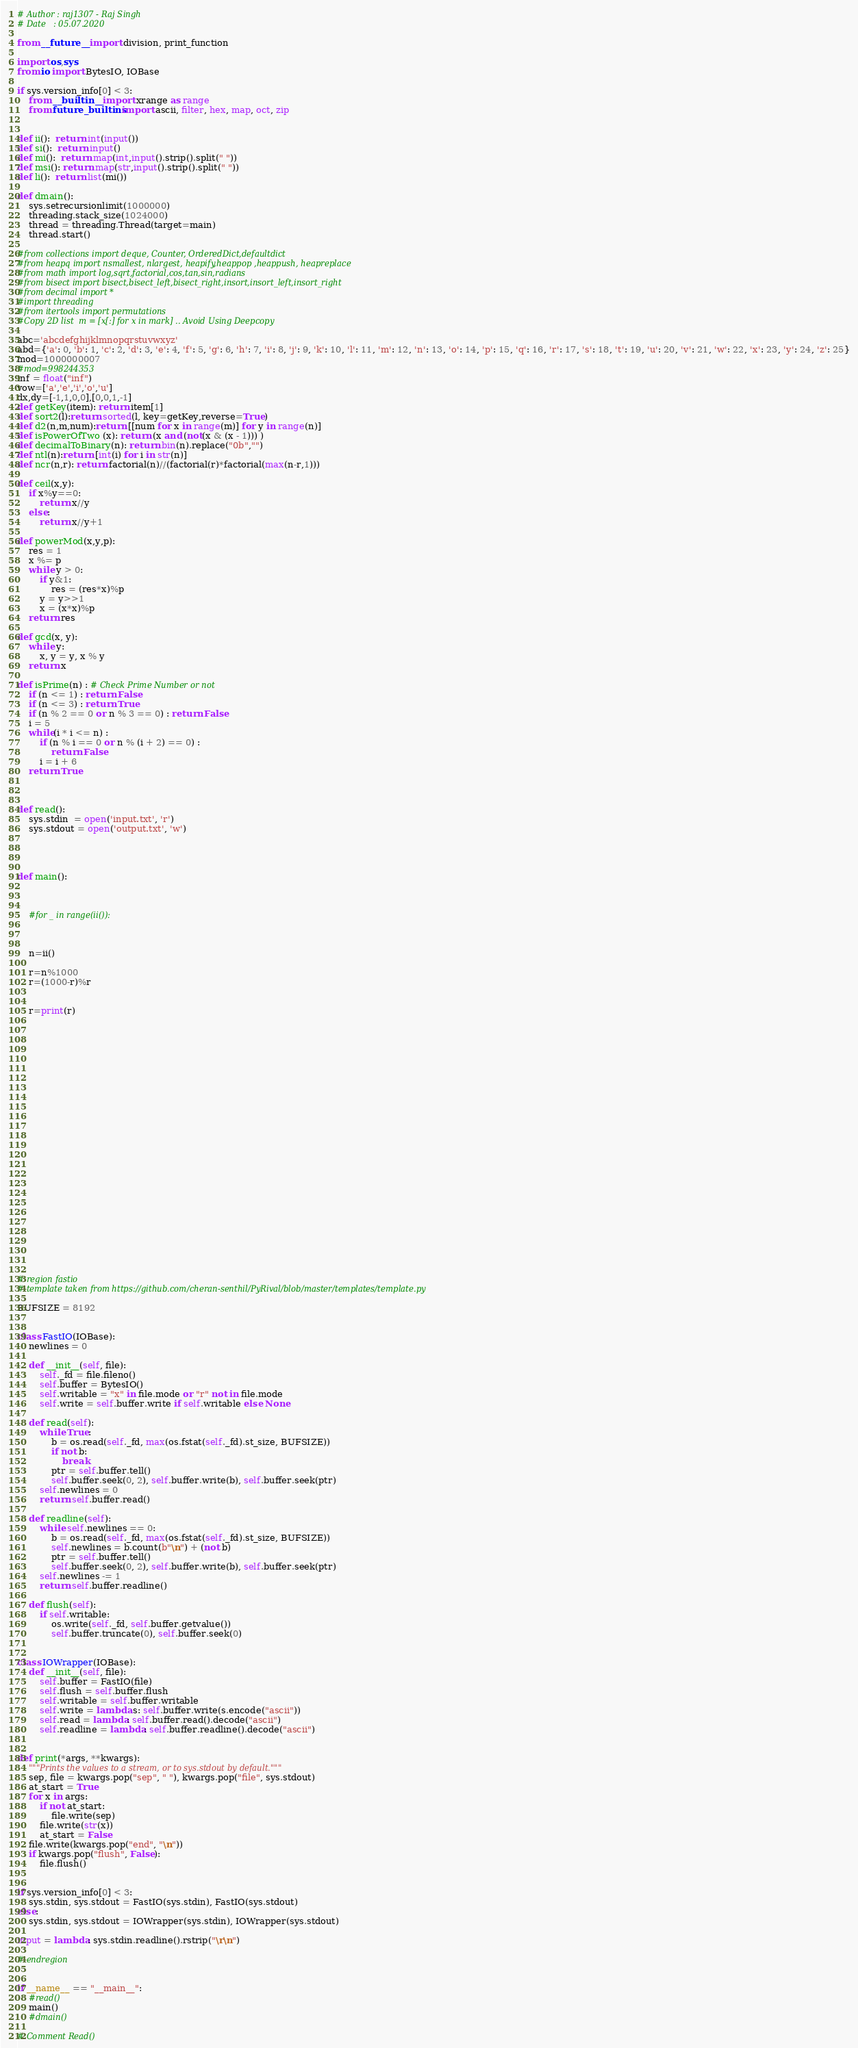<code> <loc_0><loc_0><loc_500><loc_500><_Python_>
# Author : raj1307 - Raj Singh
# Date   : 05.07.2020

from __future__ import division, print_function

import os,sys
from io import BytesIO, IOBase

if sys.version_info[0] < 3:
    from __builtin__ import xrange as range
    from future_builtins import ascii, filter, hex, map, oct, zip


def ii():  return int(input())
def si():  return input()
def mi():  return map(int,input().strip().split(" "))
def msi(): return map(str,input().strip().split(" "))
def li():  return list(mi())

def dmain():
    sys.setrecursionlimit(1000000)
    threading.stack_size(1024000)
    thread = threading.Thread(target=main)
    thread.start()
    
#from collections import deque, Counter, OrderedDict,defaultdict
#from heapq import nsmallest, nlargest, heapify,heappop ,heappush, heapreplace
#from math import log,sqrt,factorial,cos,tan,sin,radians
#from bisect import bisect,bisect_left,bisect_right,insort,insort_left,insort_right
#from decimal import *
#import threading
#from itertools import permutations
#Copy 2D list  m = [x[:] for x in mark] .. Avoid Using Deepcopy

abc='abcdefghijklmnopqrstuvwxyz'
abd={'a': 0, 'b': 1, 'c': 2, 'd': 3, 'e': 4, 'f': 5, 'g': 6, 'h': 7, 'i': 8, 'j': 9, 'k': 10, 'l': 11, 'm': 12, 'n': 13, 'o': 14, 'p': 15, 'q': 16, 'r': 17, 's': 18, 't': 19, 'u': 20, 'v': 21, 'w': 22, 'x': 23, 'y': 24, 'z': 25}
mod=1000000007
#mod=998244353
inf = float("inf")
vow=['a','e','i','o','u']
dx,dy=[-1,1,0,0],[0,0,1,-1]
def getKey(item): return item[1] 
def sort2(l):return sorted(l, key=getKey,reverse=True)
def d2(n,m,num):return [[num for x in range(m)] for y in range(n)]
def isPowerOfTwo (x): return (x and (not(x & (x - 1))) )
def decimalToBinary(n): return bin(n).replace("0b","")
def ntl(n):return [int(i) for i in str(n)]
def ncr(n,r): return factorial(n)//(factorial(r)*factorial(max(n-r,1)))

def ceil(x,y):
    if x%y==0:
        return x//y
    else:
        return x//y+1

def powerMod(x,y,p):
    res = 1
    x %= p
    while y > 0:
        if y&1:
            res = (res*x)%p
        y = y>>1
        x = (x*x)%p
    return res

def gcd(x, y):
    while y:
        x, y = y, x % y
    return x
    
def isPrime(n) : # Check Prime Number or not 
    if (n <= 1) : return False
    if (n <= 3) : return True
    if (n % 2 == 0 or n % 3 == 0) : return False
    i = 5
    while(i * i <= n) : 
        if (n % i == 0 or n % (i + 2) == 0) : 
            return False
        i = i + 6
    return True



def read():
    sys.stdin  = open('input.txt', 'r')  
    sys.stdout = open('output.txt', 'w') 




def main():
    


    #for _ in range(ii()):



    n=ii()

    r=n%1000
    r=(1000-r)%r


    r=print(r)


















    








# region fastio
# template taken from https://github.com/cheran-senthil/PyRival/blob/master/templates/template.py

BUFSIZE = 8192


class FastIO(IOBase):
    newlines = 0

    def __init__(self, file):
        self._fd = file.fileno()
        self.buffer = BytesIO()
        self.writable = "x" in file.mode or "r" not in file.mode
        self.write = self.buffer.write if self.writable else None

    def read(self):
        while True:
            b = os.read(self._fd, max(os.fstat(self._fd).st_size, BUFSIZE))
            if not b:
                break
            ptr = self.buffer.tell()
            self.buffer.seek(0, 2), self.buffer.write(b), self.buffer.seek(ptr)
        self.newlines = 0
        return self.buffer.read()

    def readline(self):
        while self.newlines == 0:
            b = os.read(self._fd, max(os.fstat(self._fd).st_size, BUFSIZE))
            self.newlines = b.count(b"\n") + (not b)
            ptr = self.buffer.tell()
            self.buffer.seek(0, 2), self.buffer.write(b), self.buffer.seek(ptr)
        self.newlines -= 1
        return self.buffer.readline()

    def flush(self):
        if self.writable:
            os.write(self._fd, self.buffer.getvalue())
            self.buffer.truncate(0), self.buffer.seek(0)


class IOWrapper(IOBase):
    def __init__(self, file):
        self.buffer = FastIO(file)
        self.flush = self.buffer.flush
        self.writable = self.buffer.writable
        self.write = lambda s: self.buffer.write(s.encode("ascii"))
        self.read = lambda: self.buffer.read().decode("ascii")
        self.readline = lambda: self.buffer.readline().decode("ascii")


def print(*args, **kwargs):
    """Prints the values to a stream, or to sys.stdout by default."""
    sep, file = kwargs.pop("sep", " "), kwargs.pop("file", sys.stdout)
    at_start = True
    for x in args:
        if not at_start:
            file.write(sep)
        file.write(str(x))
        at_start = False
    file.write(kwargs.pop("end", "\n"))
    if kwargs.pop("flush", False):
        file.flush()


if sys.version_info[0] < 3:
    sys.stdin, sys.stdout = FastIO(sys.stdin), FastIO(sys.stdout)
else:
    sys.stdin, sys.stdout = IOWrapper(sys.stdin), IOWrapper(sys.stdout)

input = lambda: sys.stdin.readline().rstrip("\r\n")

# endregion


if __name__ == "__main__":
    #read()
    main()
    #dmain()

# Comment Read()
</code> 